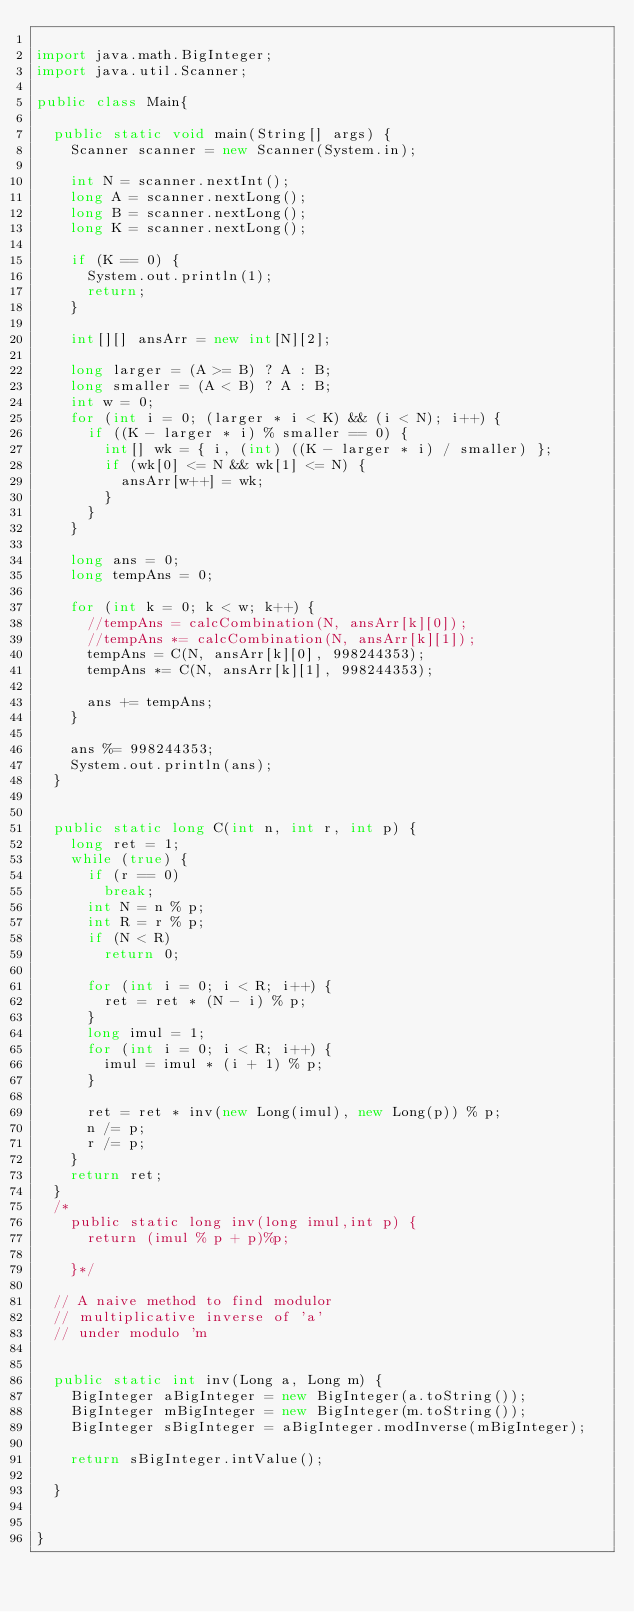<code> <loc_0><loc_0><loc_500><loc_500><_Java_>
import java.math.BigInteger;
import java.util.Scanner;

public class Main{

	public static void main(String[] args) {
		Scanner scanner = new Scanner(System.in);

		int N = scanner.nextInt();
		long A = scanner.nextLong();
		long B = scanner.nextLong();
		long K = scanner.nextLong();

		if (K == 0) {
			System.out.println(1);
			return;
		}

		int[][] ansArr = new int[N][2];

		long larger = (A >= B) ? A : B;
		long smaller = (A < B) ? A : B;
		int w = 0;
		for (int i = 0; (larger * i < K) && (i < N); i++) {
			if ((K - larger * i) % smaller == 0) {
				int[] wk = { i, (int) ((K - larger * i) / smaller) };
				if (wk[0] <= N && wk[1] <= N) {
					ansArr[w++] = wk;
				}
			}
		}

		long ans = 0;
		long tempAns = 0;

		for (int k = 0; k < w; k++) {
			//tempAns = calcCombination(N, ansArr[k][0]);
			//tempAns *= calcCombination(N, ansArr[k][1]);
			tempAns = C(N, ansArr[k][0], 998244353);
			tempAns *= C(N, ansArr[k][1], 998244353);

			ans += tempAns;
		}

		ans %= 998244353;
		System.out.println(ans);
	}


	public static long C(int n, int r, int p) {
		long ret = 1;
		while (true) {
			if (r == 0)
				break;
			int N = n % p;
			int R = r % p;
			if (N < R)
				return 0;

			for (int i = 0; i < R; i++) {
				ret = ret * (N - i) % p;
			}
			long imul = 1;
			for (int i = 0; i < R; i++) {
				imul = imul * (i + 1) % p;
			}

			ret = ret * inv(new Long(imul), new Long(p)) % p;
			n /= p;
			r /= p;
		}
		return ret;
	}
	/*
		public static long inv(long imul,int p) {
			return (imul % p + p)%p;

		}*/

	// A naive method to find modulor
	// multiplicative inverse of 'a'
	// under modulo 'm


	public static int inv(Long a, Long m) {
		BigInteger aBigInteger = new BigInteger(a.toString());
		BigInteger mBigInteger = new BigInteger(m.toString());
		BigInteger sBigInteger = aBigInteger.modInverse(mBigInteger);

		return sBigInteger.intValue();

	}


}
</code> 